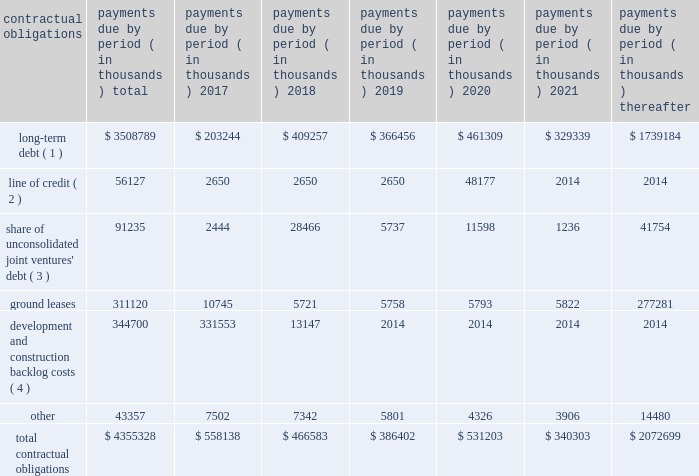
( 1 ) our long-term debt consists of both secured and unsecured debt and includes both principal and interest .
Interest payments for variable rate debt were calculated using the interest rates as of december 31 , 2016 .
Repayment of our $ 250.0 million variable rate term note , which has a contractual maturity date in january 2019 , is reflected as a 2020 obligation in the table above based on the ability to exercise a one-year extension , which we may exercise at our discretion .
( 2 ) our unsecured line of credit has a contractual maturity date in january 2019 , but is reflected as a 2020 obligation in the table above based on the ability to exercise a one-year extension , which we may exercise at our discretion .
Interest payments for our unsecured line of credit were calculated using the most recent stated interest rate that was in effect.ff ( 3 ) our share of unconsolidated joint venture debt includes both principal and interest .
Interest expense for variable rate debt was calculated using the interest rate at december 31 , 2016 .
( 4 ) represents estimated remaining costs on the completion of owned development projects and third-party construction projects .
Related party y transactionstt we provide property and asset management , leasing , construction and other tenant-related services to ww unconsolidated companies in which we have equity interests .
For the years ended december 31 , 2016 , 2015 and 2014 we earned management fees of $ 4.5 million , $ 6.8 million and $ 8.5 million , leasing fees of $ 2.4 million , $ 3.0 million and $ 3.4 million and construction and development fees of $ 8.0 million , $ 6.1 million and $ 5.8 million , respectively , from these companies , prior to elimination of our ownership percentage .
Yy we recorded these fees based ww on contractual terms that approximate market rates for these types of services and have eliminated our ownership percentages of these fees in the consolidated financial statements .
Commitments and contingenciesg the partnership has guaranteed the repayment of $ 32.9 million of economic development bonds issued by various municipalities in connection with certain commercial developments .
We will be required to make payments under ww our guarantees to the extent that incremental taxes from specified developments are not sufficient to pay the bond ff debt service .
Management does not believe that it is probable that we will be required to make any significant payments in satisfaction of these guarantees .
The partnership also has guaranteed the repayment of an unsecured loan of one of our unconsolidated subsidiaries .
At december 31 , 2016 , the maximum guarantee exposure for this loan was approximately $ 52.1 million .
We lease certain land positions with terms extending toww march 2114 , with a total future payment obligation of $ 311.1 million .
The payments on these ground leases , which are classified as operating leases , are not material in any individual year .
In addition to ground leases , we are party to other operating leases as part of conducting our business , including leases of office space from third parties , with a total future payment obligation of ff $ 43.4 million at december 31 , 2016 .
No future payments on these leases are material in any individual year .
We are subject to various legal proceedings and claims that arise in the ordinary course of business .
In the opinion ww of management , the amount of any ultimate liability with respect to these actions is not expected to materially affect ff our consolidated financial statements or results of operations .
We own certain parcels of land that are subject to special property tax assessments levied by quasi municipalww entities .
To the extent that such special assessments are fixed and determinable , the discounted value of the fulltt .
What was the percent of the total contractual obligations that was associated with long-term debt that was due in 2017? 
Rationale: [10] : for the years ended december 31 , 2016 , 2015 and 2014 we earned management fees of $ 4.5 million , $ 6.8 million and $ 8.5 million , leasing fees of $ 2.4 million , $ 3.0 million and $ 3.4 million and construction and development fees of $ 8.0 million , $ 6.1 million and $ 5.8 million , respectively , from these companies , prior to elimination of our ownership percentage .
Computations: (203244 / 3508789)
Answer: 0.05792. 